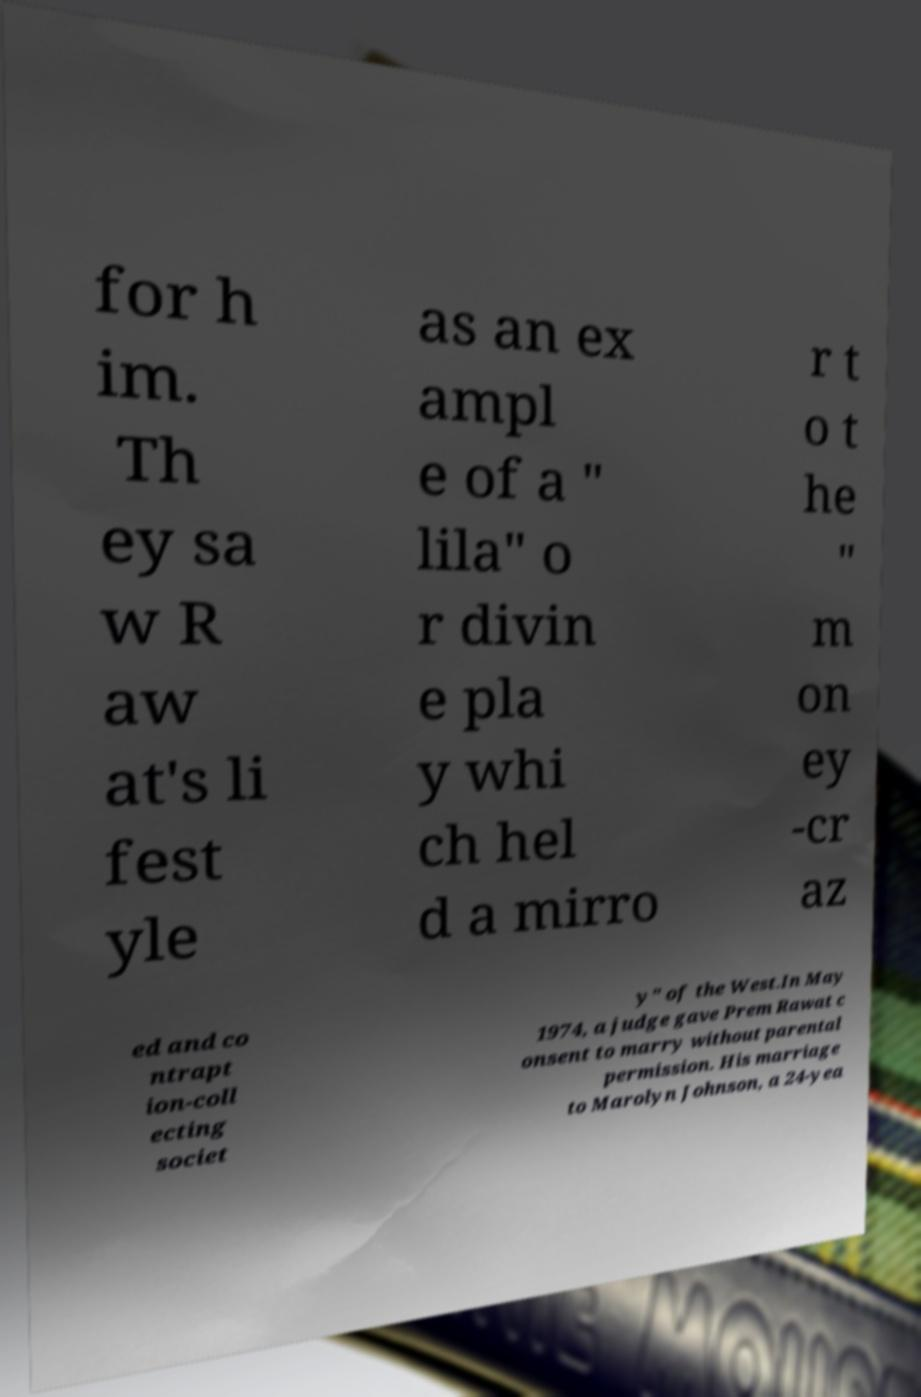What messages or text are displayed in this image? I need them in a readable, typed format. for h im. Th ey sa w R aw at's li fest yle as an ex ampl e of a " lila" o r divin e pla y whi ch hel d a mirro r t o t he " m on ey -cr az ed and co ntrapt ion-coll ecting societ y" of the West.In May 1974, a judge gave Prem Rawat c onsent to marry without parental permission. His marriage to Marolyn Johnson, a 24-yea 